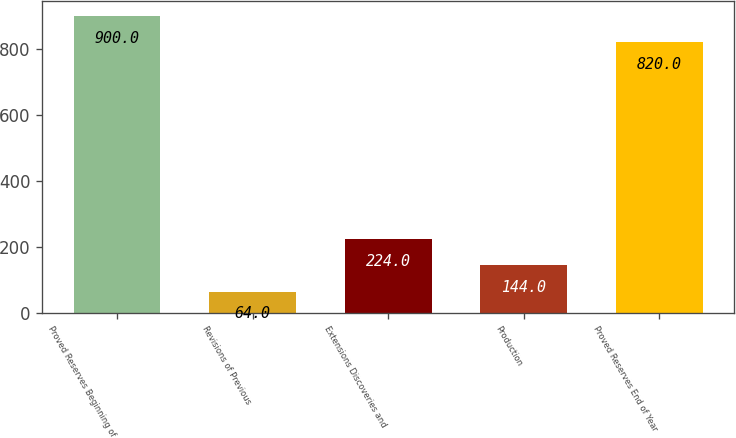Convert chart to OTSL. <chart><loc_0><loc_0><loc_500><loc_500><bar_chart><fcel>Proved Reserves Beginning of<fcel>Revisions of Previous<fcel>Extensions Discoveries and<fcel>Production<fcel>Proved Reserves End of Year<nl><fcel>900<fcel>64<fcel>224<fcel>144<fcel>820<nl></chart> 